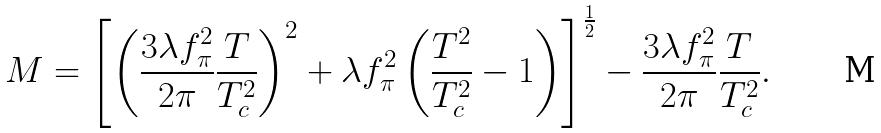Convert formula to latex. <formula><loc_0><loc_0><loc_500><loc_500>M = \left [ \left ( \frac { 3 \lambda f _ { \pi } ^ { 2 } } { 2 \pi } \frac { T } { T _ { c } ^ { 2 } } \right ) ^ { 2 } + \lambda f _ { \pi } ^ { 2 } \left ( \frac { T ^ { 2 } } { T _ { c } ^ { 2 } } - 1 \right ) \right ] ^ { \frac { 1 } { 2 } } - \frac { 3 \lambda f _ { \pi } ^ { 2 } } { 2 \pi } \frac { T } { T _ { c } ^ { 2 } } .</formula> 